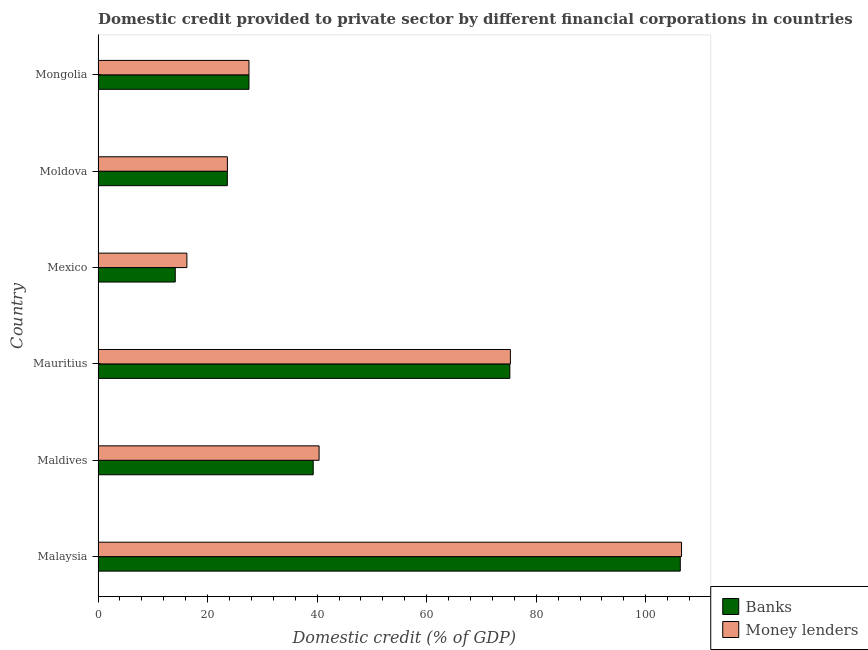How many different coloured bars are there?
Offer a very short reply. 2. How many bars are there on the 1st tick from the top?
Provide a short and direct response. 2. How many bars are there on the 1st tick from the bottom?
Provide a succinct answer. 2. What is the label of the 4th group of bars from the top?
Ensure brevity in your answer.  Mauritius. What is the domestic credit provided by banks in Malaysia?
Your answer should be very brief. 106.29. Across all countries, what is the maximum domestic credit provided by banks?
Your answer should be compact. 106.29. Across all countries, what is the minimum domestic credit provided by banks?
Offer a very short reply. 14.1. In which country was the domestic credit provided by money lenders maximum?
Offer a very short reply. Malaysia. What is the total domestic credit provided by money lenders in the graph?
Your answer should be compact. 289.54. What is the difference between the domestic credit provided by money lenders in Maldives and that in Mongolia?
Keep it short and to the point. 12.8. What is the difference between the domestic credit provided by banks in Malaysia and the domestic credit provided by money lenders in Mexico?
Give a very brief answer. 90.07. What is the average domestic credit provided by banks per country?
Provide a succinct answer. 47.67. What is the difference between the domestic credit provided by money lenders and domestic credit provided by banks in Mexico?
Give a very brief answer. 2.12. In how many countries, is the domestic credit provided by banks greater than 8 %?
Make the answer very short. 6. What is the ratio of the domestic credit provided by banks in Malaysia to that in Mongolia?
Provide a short and direct response. 3.86. Is the difference between the domestic credit provided by banks in Mexico and Mongolia greater than the difference between the domestic credit provided by money lenders in Mexico and Mongolia?
Your answer should be very brief. No. What is the difference between the highest and the second highest domestic credit provided by money lenders?
Your response must be concise. 31.25. What is the difference between the highest and the lowest domestic credit provided by money lenders?
Your response must be concise. 90.31. What does the 1st bar from the top in Maldives represents?
Your answer should be very brief. Money lenders. What does the 1st bar from the bottom in Mauritius represents?
Your answer should be very brief. Banks. How many countries are there in the graph?
Offer a very short reply. 6. Does the graph contain grids?
Make the answer very short. No. Where does the legend appear in the graph?
Give a very brief answer. Bottom right. How many legend labels are there?
Provide a succinct answer. 2. What is the title of the graph?
Make the answer very short. Domestic credit provided to private sector by different financial corporations in countries. What is the label or title of the X-axis?
Provide a succinct answer. Domestic credit (% of GDP). What is the label or title of the Y-axis?
Your answer should be very brief. Country. What is the Domestic credit (% of GDP) in Banks in Malaysia?
Your answer should be very brief. 106.29. What is the Domestic credit (% of GDP) in Money lenders in Malaysia?
Provide a succinct answer. 106.52. What is the Domestic credit (% of GDP) in Banks in Maldives?
Provide a succinct answer. 39.28. What is the Domestic credit (% of GDP) in Money lenders in Maldives?
Keep it short and to the point. 40.35. What is the Domestic credit (% of GDP) in Banks in Mauritius?
Your answer should be compact. 75.18. What is the Domestic credit (% of GDP) in Money lenders in Mauritius?
Provide a succinct answer. 75.28. What is the Domestic credit (% of GDP) in Banks in Mexico?
Your response must be concise. 14.1. What is the Domestic credit (% of GDP) of Money lenders in Mexico?
Offer a terse response. 16.22. What is the Domestic credit (% of GDP) of Banks in Moldova?
Provide a succinct answer. 23.6. What is the Domestic credit (% of GDP) of Money lenders in Moldova?
Your answer should be compact. 23.61. What is the Domestic credit (% of GDP) in Banks in Mongolia?
Your answer should be compact. 27.55. What is the Domestic credit (% of GDP) in Money lenders in Mongolia?
Ensure brevity in your answer.  27.55. Across all countries, what is the maximum Domestic credit (% of GDP) of Banks?
Offer a very short reply. 106.29. Across all countries, what is the maximum Domestic credit (% of GDP) in Money lenders?
Your answer should be compact. 106.52. Across all countries, what is the minimum Domestic credit (% of GDP) in Banks?
Your answer should be compact. 14.1. Across all countries, what is the minimum Domestic credit (% of GDP) in Money lenders?
Your answer should be compact. 16.22. What is the total Domestic credit (% of GDP) in Banks in the graph?
Keep it short and to the point. 286. What is the total Domestic credit (% of GDP) of Money lenders in the graph?
Provide a short and direct response. 289.54. What is the difference between the Domestic credit (% of GDP) of Banks in Malaysia and that in Maldives?
Keep it short and to the point. 67.01. What is the difference between the Domestic credit (% of GDP) in Money lenders in Malaysia and that in Maldives?
Provide a succinct answer. 66.17. What is the difference between the Domestic credit (% of GDP) in Banks in Malaysia and that in Mauritius?
Your answer should be very brief. 31.12. What is the difference between the Domestic credit (% of GDP) in Money lenders in Malaysia and that in Mauritius?
Offer a terse response. 31.25. What is the difference between the Domestic credit (% of GDP) in Banks in Malaysia and that in Mexico?
Ensure brevity in your answer.  92.2. What is the difference between the Domestic credit (% of GDP) of Money lenders in Malaysia and that in Mexico?
Make the answer very short. 90.31. What is the difference between the Domestic credit (% of GDP) in Banks in Malaysia and that in Moldova?
Provide a short and direct response. 82.69. What is the difference between the Domestic credit (% of GDP) in Money lenders in Malaysia and that in Moldova?
Your answer should be compact. 82.91. What is the difference between the Domestic credit (% of GDP) of Banks in Malaysia and that in Mongolia?
Provide a succinct answer. 78.74. What is the difference between the Domestic credit (% of GDP) of Money lenders in Malaysia and that in Mongolia?
Offer a very short reply. 78.97. What is the difference between the Domestic credit (% of GDP) in Banks in Maldives and that in Mauritius?
Make the answer very short. -35.9. What is the difference between the Domestic credit (% of GDP) of Money lenders in Maldives and that in Mauritius?
Offer a very short reply. -34.92. What is the difference between the Domestic credit (% of GDP) in Banks in Maldives and that in Mexico?
Ensure brevity in your answer.  25.18. What is the difference between the Domestic credit (% of GDP) of Money lenders in Maldives and that in Mexico?
Your answer should be compact. 24.13. What is the difference between the Domestic credit (% of GDP) in Banks in Maldives and that in Moldova?
Your answer should be compact. 15.68. What is the difference between the Domestic credit (% of GDP) of Money lenders in Maldives and that in Moldova?
Your answer should be very brief. 16.74. What is the difference between the Domestic credit (% of GDP) of Banks in Maldives and that in Mongolia?
Provide a short and direct response. 11.73. What is the difference between the Domestic credit (% of GDP) of Money lenders in Maldives and that in Mongolia?
Offer a terse response. 12.8. What is the difference between the Domestic credit (% of GDP) in Banks in Mauritius and that in Mexico?
Give a very brief answer. 61.08. What is the difference between the Domestic credit (% of GDP) in Money lenders in Mauritius and that in Mexico?
Give a very brief answer. 59.06. What is the difference between the Domestic credit (% of GDP) in Banks in Mauritius and that in Moldova?
Offer a very short reply. 51.58. What is the difference between the Domestic credit (% of GDP) in Money lenders in Mauritius and that in Moldova?
Offer a terse response. 51.66. What is the difference between the Domestic credit (% of GDP) of Banks in Mauritius and that in Mongolia?
Offer a very short reply. 47.63. What is the difference between the Domestic credit (% of GDP) of Money lenders in Mauritius and that in Mongolia?
Offer a very short reply. 47.73. What is the difference between the Domestic credit (% of GDP) in Banks in Mexico and that in Moldova?
Your answer should be very brief. -9.51. What is the difference between the Domestic credit (% of GDP) of Money lenders in Mexico and that in Moldova?
Keep it short and to the point. -7.39. What is the difference between the Domestic credit (% of GDP) of Banks in Mexico and that in Mongolia?
Provide a succinct answer. -13.46. What is the difference between the Domestic credit (% of GDP) of Money lenders in Mexico and that in Mongolia?
Offer a very short reply. -11.33. What is the difference between the Domestic credit (% of GDP) of Banks in Moldova and that in Mongolia?
Your answer should be compact. -3.95. What is the difference between the Domestic credit (% of GDP) of Money lenders in Moldova and that in Mongolia?
Your answer should be very brief. -3.94. What is the difference between the Domestic credit (% of GDP) of Banks in Malaysia and the Domestic credit (% of GDP) of Money lenders in Maldives?
Your response must be concise. 65.94. What is the difference between the Domestic credit (% of GDP) in Banks in Malaysia and the Domestic credit (% of GDP) in Money lenders in Mauritius?
Your answer should be compact. 31.02. What is the difference between the Domestic credit (% of GDP) of Banks in Malaysia and the Domestic credit (% of GDP) of Money lenders in Mexico?
Offer a terse response. 90.07. What is the difference between the Domestic credit (% of GDP) in Banks in Malaysia and the Domestic credit (% of GDP) in Money lenders in Moldova?
Ensure brevity in your answer.  82.68. What is the difference between the Domestic credit (% of GDP) of Banks in Malaysia and the Domestic credit (% of GDP) of Money lenders in Mongolia?
Your answer should be compact. 78.74. What is the difference between the Domestic credit (% of GDP) in Banks in Maldives and the Domestic credit (% of GDP) in Money lenders in Mauritius?
Your answer should be compact. -36. What is the difference between the Domestic credit (% of GDP) of Banks in Maldives and the Domestic credit (% of GDP) of Money lenders in Mexico?
Offer a terse response. 23.06. What is the difference between the Domestic credit (% of GDP) in Banks in Maldives and the Domestic credit (% of GDP) in Money lenders in Moldova?
Your answer should be very brief. 15.66. What is the difference between the Domestic credit (% of GDP) in Banks in Maldives and the Domestic credit (% of GDP) in Money lenders in Mongolia?
Keep it short and to the point. 11.73. What is the difference between the Domestic credit (% of GDP) in Banks in Mauritius and the Domestic credit (% of GDP) in Money lenders in Mexico?
Make the answer very short. 58.96. What is the difference between the Domestic credit (% of GDP) of Banks in Mauritius and the Domestic credit (% of GDP) of Money lenders in Moldova?
Make the answer very short. 51.56. What is the difference between the Domestic credit (% of GDP) of Banks in Mauritius and the Domestic credit (% of GDP) of Money lenders in Mongolia?
Your answer should be very brief. 47.63. What is the difference between the Domestic credit (% of GDP) in Banks in Mexico and the Domestic credit (% of GDP) in Money lenders in Moldova?
Give a very brief answer. -9.52. What is the difference between the Domestic credit (% of GDP) in Banks in Mexico and the Domestic credit (% of GDP) in Money lenders in Mongolia?
Ensure brevity in your answer.  -13.46. What is the difference between the Domestic credit (% of GDP) of Banks in Moldova and the Domestic credit (% of GDP) of Money lenders in Mongolia?
Offer a very short reply. -3.95. What is the average Domestic credit (% of GDP) in Banks per country?
Your answer should be compact. 47.67. What is the average Domestic credit (% of GDP) in Money lenders per country?
Provide a short and direct response. 48.26. What is the difference between the Domestic credit (% of GDP) of Banks and Domestic credit (% of GDP) of Money lenders in Malaysia?
Provide a succinct answer. -0.23. What is the difference between the Domestic credit (% of GDP) in Banks and Domestic credit (% of GDP) in Money lenders in Maldives?
Provide a succinct answer. -1.08. What is the difference between the Domestic credit (% of GDP) of Banks and Domestic credit (% of GDP) of Money lenders in Mauritius?
Ensure brevity in your answer.  -0.1. What is the difference between the Domestic credit (% of GDP) of Banks and Domestic credit (% of GDP) of Money lenders in Mexico?
Offer a terse response. -2.12. What is the difference between the Domestic credit (% of GDP) of Banks and Domestic credit (% of GDP) of Money lenders in Moldova?
Provide a succinct answer. -0.01. What is the difference between the Domestic credit (% of GDP) of Banks and Domestic credit (% of GDP) of Money lenders in Mongolia?
Keep it short and to the point. 0. What is the ratio of the Domestic credit (% of GDP) in Banks in Malaysia to that in Maldives?
Your response must be concise. 2.71. What is the ratio of the Domestic credit (% of GDP) in Money lenders in Malaysia to that in Maldives?
Your response must be concise. 2.64. What is the ratio of the Domestic credit (% of GDP) of Banks in Malaysia to that in Mauritius?
Provide a succinct answer. 1.41. What is the ratio of the Domestic credit (% of GDP) in Money lenders in Malaysia to that in Mauritius?
Your response must be concise. 1.42. What is the ratio of the Domestic credit (% of GDP) in Banks in Malaysia to that in Mexico?
Keep it short and to the point. 7.54. What is the ratio of the Domestic credit (% of GDP) in Money lenders in Malaysia to that in Mexico?
Your answer should be compact. 6.57. What is the ratio of the Domestic credit (% of GDP) of Banks in Malaysia to that in Moldova?
Give a very brief answer. 4.5. What is the ratio of the Domestic credit (% of GDP) in Money lenders in Malaysia to that in Moldova?
Make the answer very short. 4.51. What is the ratio of the Domestic credit (% of GDP) of Banks in Malaysia to that in Mongolia?
Make the answer very short. 3.86. What is the ratio of the Domestic credit (% of GDP) in Money lenders in Malaysia to that in Mongolia?
Provide a succinct answer. 3.87. What is the ratio of the Domestic credit (% of GDP) in Banks in Maldives to that in Mauritius?
Make the answer very short. 0.52. What is the ratio of the Domestic credit (% of GDP) in Money lenders in Maldives to that in Mauritius?
Offer a terse response. 0.54. What is the ratio of the Domestic credit (% of GDP) of Banks in Maldives to that in Mexico?
Your answer should be very brief. 2.79. What is the ratio of the Domestic credit (% of GDP) in Money lenders in Maldives to that in Mexico?
Ensure brevity in your answer.  2.49. What is the ratio of the Domestic credit (% of GDP) in Banks in Maldives to that in Moldova?
Provide a succinct answer. 1.66. What is the ratio of the Domestic credit (% of GDP) of Money lenders in Maldives to that in Moldova?
Give a very brief answer. 1.71. What is the ratio of the Domestic credit (% of GDP) of Banks in Maldives to that in Mongolia?
Give a very brief answer. 1.43. What is the ratio of the Domestic credit (% of GDP) in Money lenders in Maldives to that in Mongolia?
Your answer should be compact. 1.46. What is the ratio of the Domestic credit (% of GDP) in Banks in Mauritius to that in Mexico?
Offer a terse response. 5.33. What is the ratio of the Domestic credit (% of GDP) of Money lenders in Mauritius to that in Mexico?
Keep it short and to the point. 4.64. What is the ratio of the Domestic credit (% of GDP) of Banks in Mauritius to that in Moldova?
Your response must be concise. 3.19. What is the ratio of the Domestic credit (% of GDP) of Money lenders in Mauritius to that in Moldova?
Offer a terse response. 3.19. What is the ratio of the Domestic credit (% of GDP) in Banks in Mauritius to that in Mongolia?
Your answer should be very brief. 2.73. What is the ratio of the Domestic credit (% of GDP) of Money lenders in Mauritius to that in Mongolia?
Your answer should be compact. 2.73. What is the ratio of the Domestic credit (% of GDP) of Banks in Mexico to that in Moldova?
Ensure brevity in your answer.  0.6. What is the ratio of the Domestic credit (% of GDP) in Money lenders in Mexico to that in Moldova?
Ensure brevity in your answer.  0.69. What is the ratio of the Domestic credit (% of GDP) in Banks in Mexico to that in Mongolia?
Offer a very short reply. 0.51. What is the ratio of the Domestic credit (% of GDP) in Money lenders in Mexico to that in Mongolia?
Your answer should be compact. 0.59. What is the ratio of the Domestic credit (% of GDP) of Banks in Moldova to that in Mongolia?
Offer a terse response. 0.86. What is the difference between the highest and the second highest Domestic credit (% of GDP) in Banks?
Your answer should be very brief. 31.12. What is the difference between the highest and the second highest Domestic credit (% of GDP) of Money lenders?
Provide a succinct answer. 31.25. What is the difference between the highest and the lowest Domestic credit (% of GDP) in Banks?
Make the answer very short. 92.2. What is the difference between the highest and the lowest Domestic credit (% of GDP) in Money lenders?
Your answer should be very brief. 90.31. 